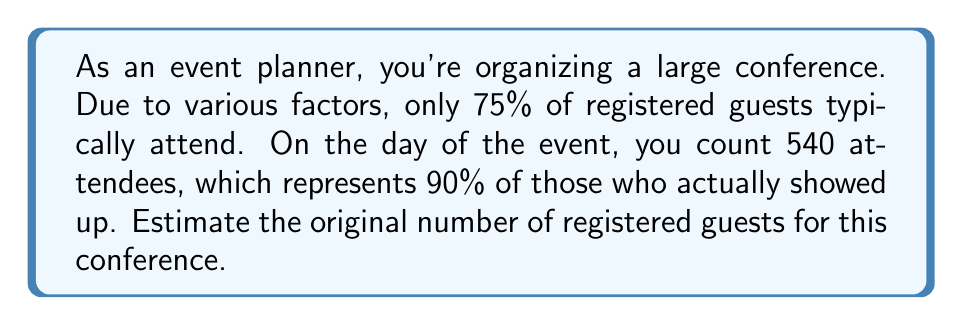Can you answer this question? Let's approach this step-by-step:

1) Let $x$ be the original number of registered guests.

2) We know that typically 75% of registered guests attend. So, the expected number of attendees would be:
   $$0.75x$$

3) We're told that the 540 counted attendees represent 90% of those who actually showed up. Let's call the actual number of attendees $y$. We can write:
   $$540 = 0.90y$$

4) Solving for $y$:
   $$y = \frac{540}{0.90} = 600$$

5) So, 600 people actually attended the event. This should represent 75% of the original registrations:
   $$600 = 0.75x$$

6) Now we can solve for $x$:
   $$x = \frac{600}{0.75} = 800$$

Therefore, we estimate that there were originally 800 registered guests.
Answer: 800 guests 